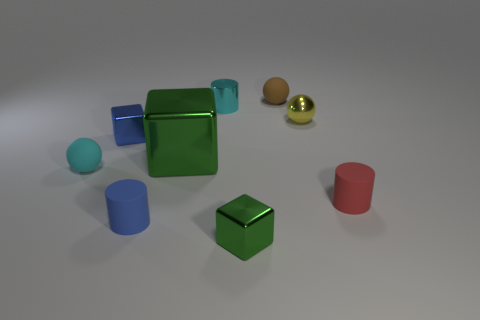Subtract all rubber spheres. How many spheres are left? 1 Subtract all blue blocks. How many blocks are left? 2 Add 1 brown things. How many objects exist? 10 Subtract 0 green cylinders. How many objects are left? 9 Subtract all cylinders. How many objects are left? 6 Subtract 2 blocks. How many blocks are left? 1 Subtract all red cubes. Subtract all green cylinders. How many cubes are left? 3 Subtract all red balls. How many blue cylinders are left? 1 Subtract all yellow spheres. Subtract all small shiny objects. How many objects are left? 4 Add 2 tiny cyan cylinders. How many tiny cyan cylinders are left? 3 